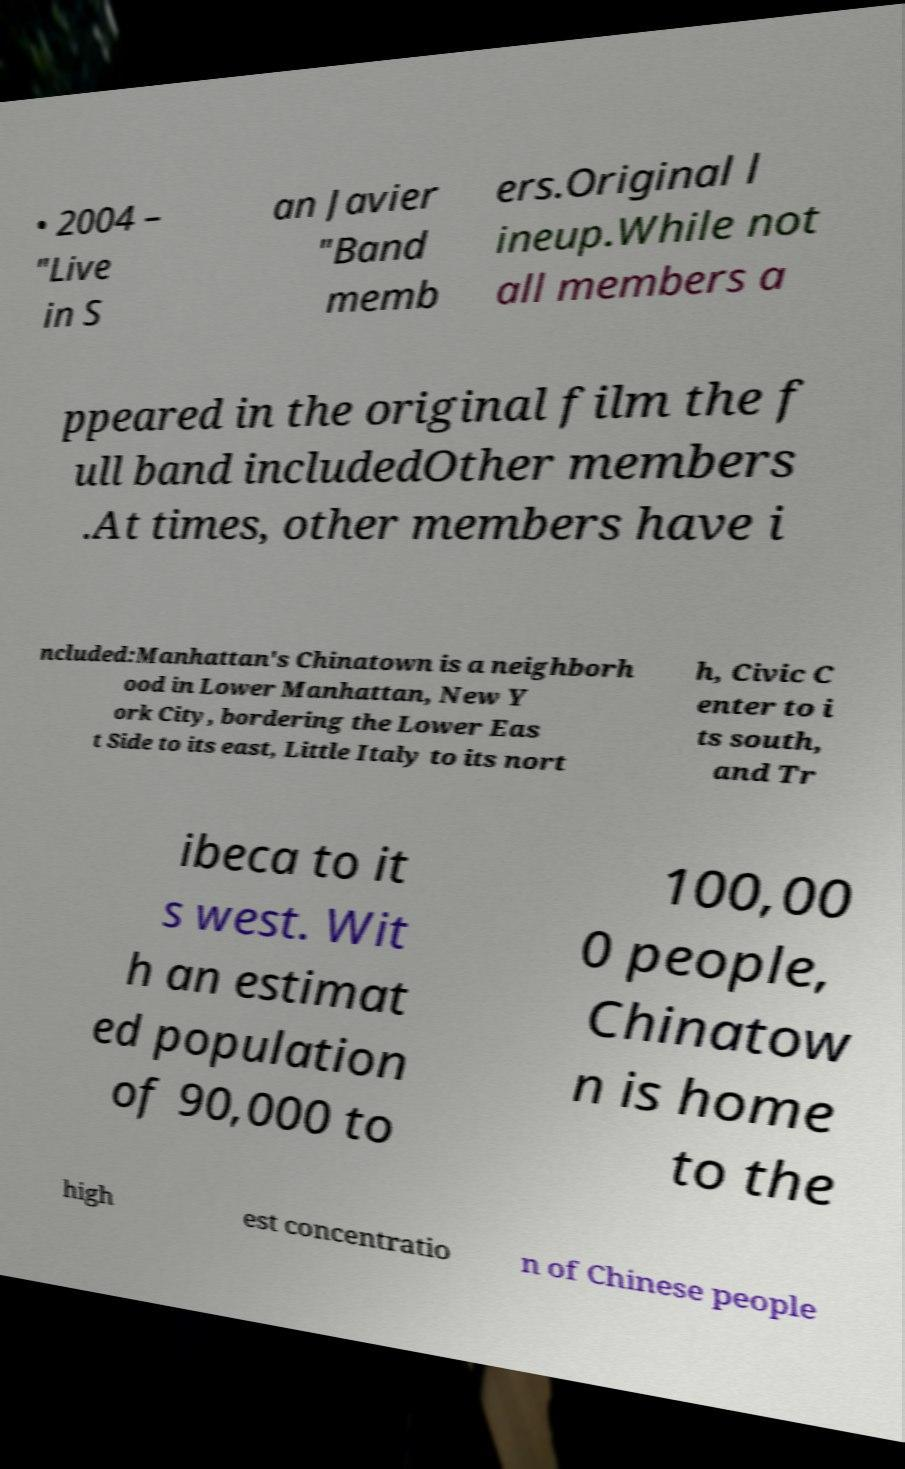What messages or text are displayed in this image? I need them in a readable, typed format. • 2004 – "Live in S an Javier "Band memb ers.Original l ineup.While not all members a ppeared in the original film the f ull band includedOther members .At times, other members have i ncluded:Manhattan's Chinatown is a neighborh ood in Lower Manhattan, New Y ork City, bordering the Lower Eas t Side to its east, Little Italy to its nort h, Civic C enter to i ts south, and Tr ibeca to it s west. Wit h an estimat ed population of 90,000 to 100,00 0 people, Chinatow n is home to the high est concentratio n of Chinese people 